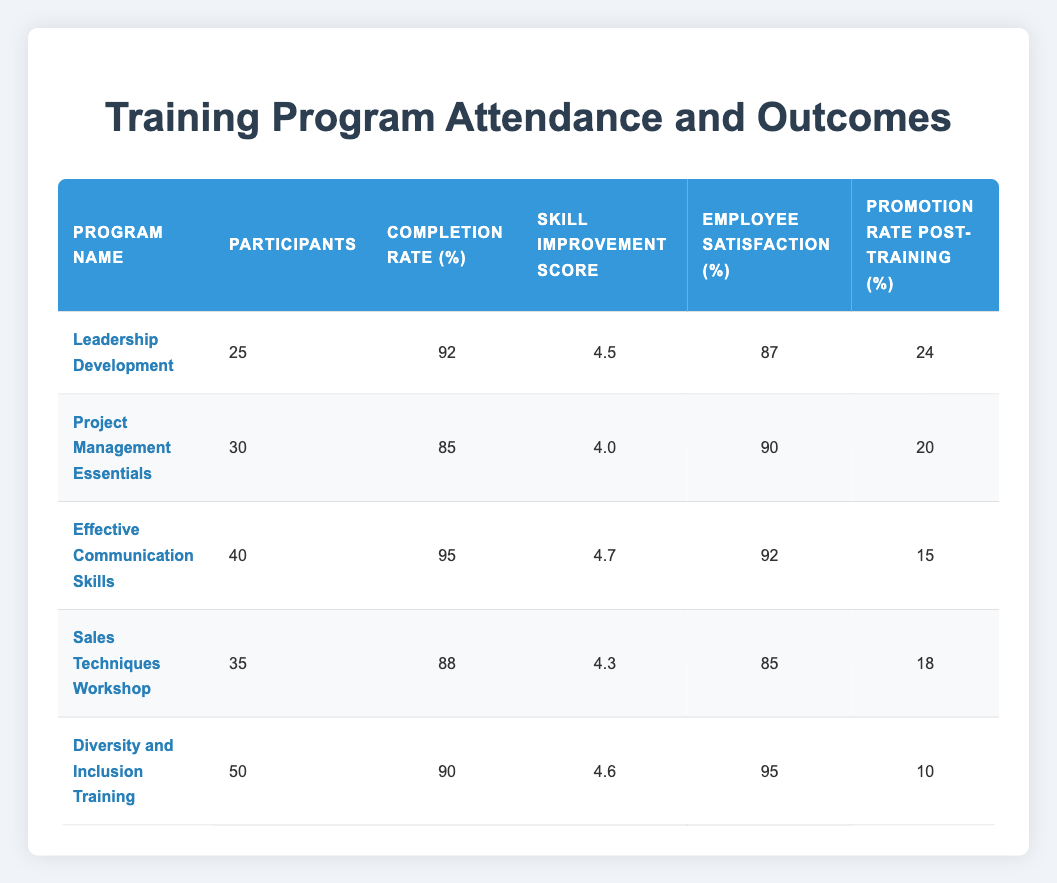What is the completion rate for the "Leadership Development" program? The completion rate for the "Leadership Development" program is listed directly in the table under the "Completion Rate (%)" column, and it shows 92.
Answer: 92 How many participants attended the "Effective Communication Skills" program? The "Effective Communication Skills" program has 40 participants, as indicated in the "Participants" column for that row.
Answer: 40 What is the average skill improvement score across all training programs? To find the average skill improvement score, we add the skill improvement scores: 4.5 + 4.0 + 4.7 + 4.3 + 4.6 = 22.1, and divide by the number of programs (5): 22.1 / 5 = 4.42.
Answer: 4.42 Is the employee satisfaction rate for the "Diversity and Inclusion Training" higher than 90? The employee satisfaction rate for the "Diversity and Inclusion Training" is 95, which is indeed higher than 90.
Answer: Yes Which program has the highest promotion rate post-training? We can compare the "Promotion Rate Post-Training (%)" across all programs: 24, 20, 15, 18, and 10. The highest is 24 for the "Leadership Development" program.
Answer: Leadership Development What is the total number of participants across all training programs? We sum the number of participants from each program: 25 + 30 + 40 + 35 + 50 = 180. This gives us the total number of participants for all programs combined.
Answer: 180 Do more participants attend the "Sales Techniques Workshop" or the "Project Management Essentials" program? There are 35 participants in the "Sales Techniques Workshop" and 30 in the "Project Management Essentials" program. Since 35 is greater than 30, more participants attended the "Sales Techniques Workshop."
Answer: Sales Techniques Workshop What is the difference in employee satisfaction between the "Effective Communication Skills" and "Sales Techniques Workshop" programs? The employee satisfaction for "Effective Communication Skills" is 92, and for "Sales Techniques Workshop," it is 85. The difference is 92 - 85 = 7.
Answer: 7 Which program has the lowest completion rate? Looking at the completion rates, "Project Management Essentials" has a completion rate of 85, which is lower than the others (92, 95, 88, 90). Hence, it has the lowest completion rate.
Answer: Project Management Essentials 